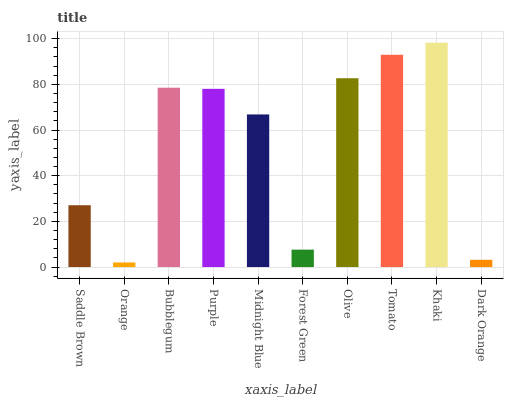Is Orange the minimum?
Answer yes or no. Yes. Is Khaki the maximum?
Answer yes or no. Yes. Is Bubblegum the minimum?
Answer yes or no. No. Is Bubblegum the maximum?
Answer yes or no. No. Is Bubblegum greater than Orange?
Answer yes or no. Yes. Is Orange less than Bubblegum?
Answer yes or no. Yes. Is Orange greater than Bubblegum?
Answer yes or no. No. Is Bubblegum less than Orange?
Answer yes or no. No. Is Purple the high median?
Answer yes or no. Yes. Is Midnight Blue the low median?
Answer yes or no. Yes. Is Tomato the high median?
Answer yes or no. No. Is Bubblegum the low median?
Answer yes or no. No. 